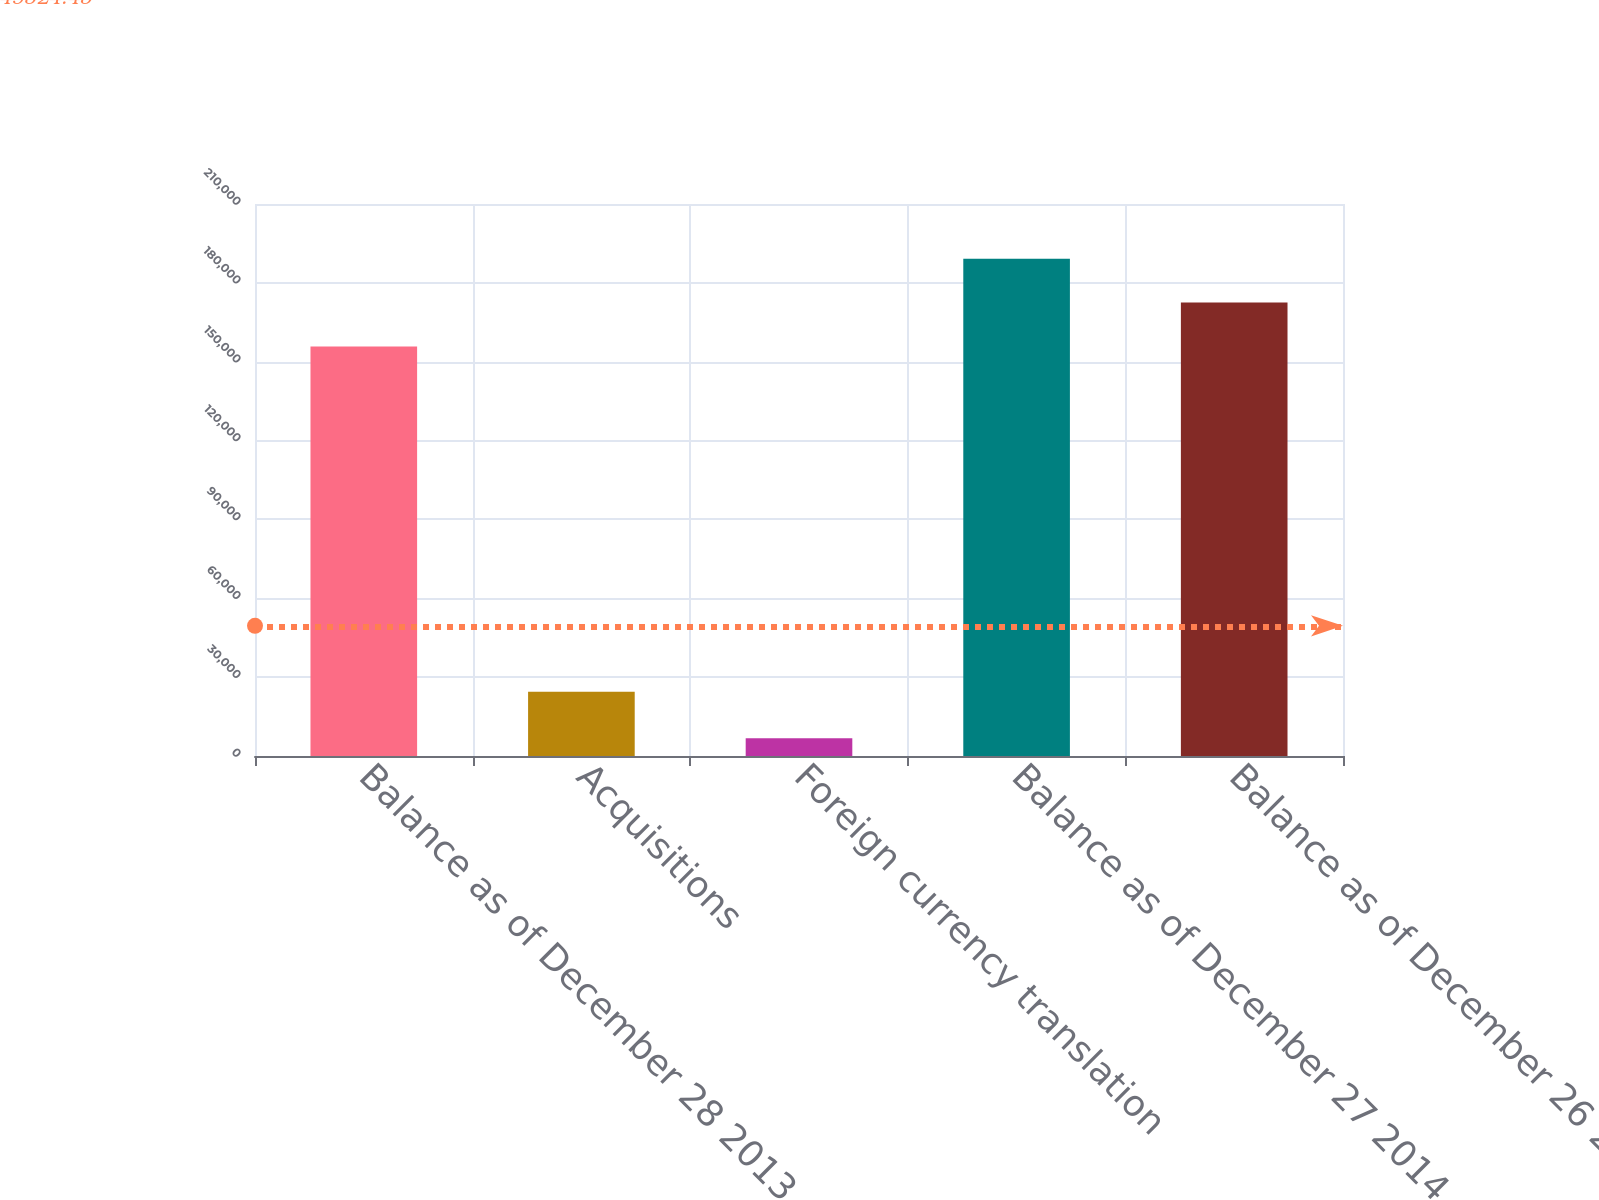<chart> <loc_0><loc_0><loc_500><loc_500><bar_chart><fcel>Balance as of December 28 2013<fcel>Acquisitions<fcel>Foreign currency translation<fcel>Balance as of December 27 2014<fcel>Balance as of December 26 2015<nl><fcel>155828<fcel>24457<fcel>6716<fcel>189199<fcel>172513<nl></chart> 